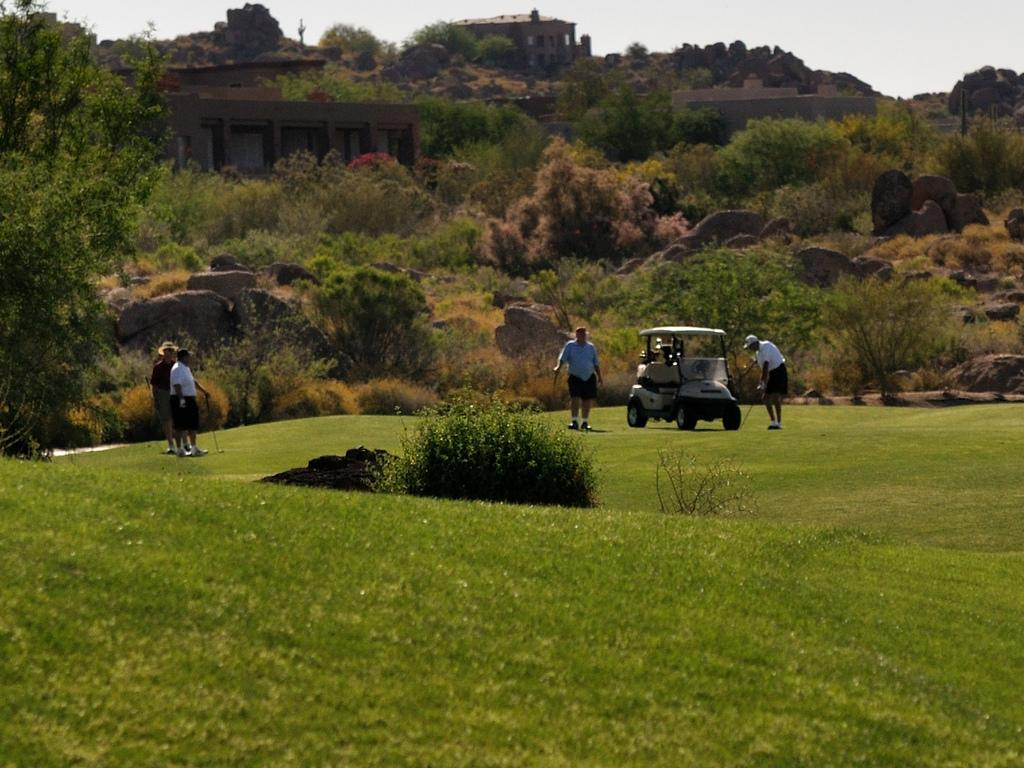What can be seen in the foreground of the image? There is greenery in the foreground of the image. Can you describe the people in the image? There are people in the image. What is located on the grassland in the image? There is a vehicle on the grassland in the image. What type of natural elements are visible in the background of the image? There are trees and stones in the background of the image. What type of structure can be seen in the background of the image? There is a building structure in the background of the image. What is visible in the sky in the background of the image? The sky is visible in the background of the image. What type of office can be seen in the image? There is no office present in the image. What event is taking place in the image? The image does not depict a specific event; it shows a scene with greenery, people, a vehicle, trees, stones, a building structure, and the sky. 